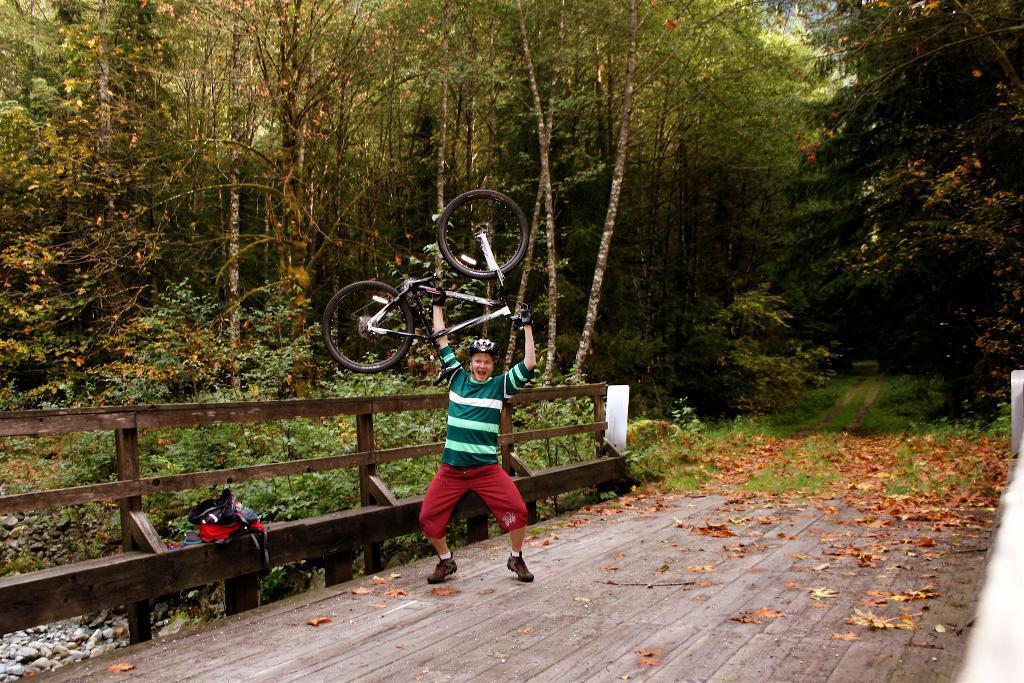Describe this image in one or two sentences. In the center of the picture there is a man holding a bicycle. In the foreground there is a bridge. On the right there are dry leaves, plants, grass and trees. In the background there are trees. On the left there are stones and plants. 